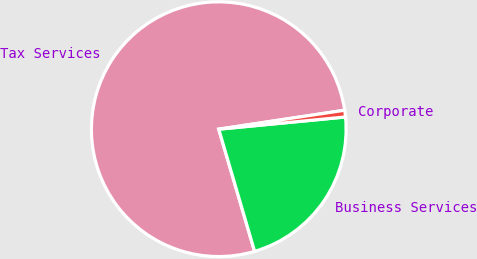<chart> <loc_0><loc_0><loc_500><loc_500><pie_chart><fcel>Tax Services<fcel>Business Services<fcel>Corporate<nl><fcel>77.16%<fcel>21.99%<fcel>0.85%<nl></chart> 